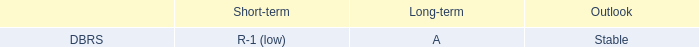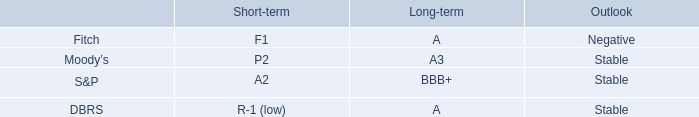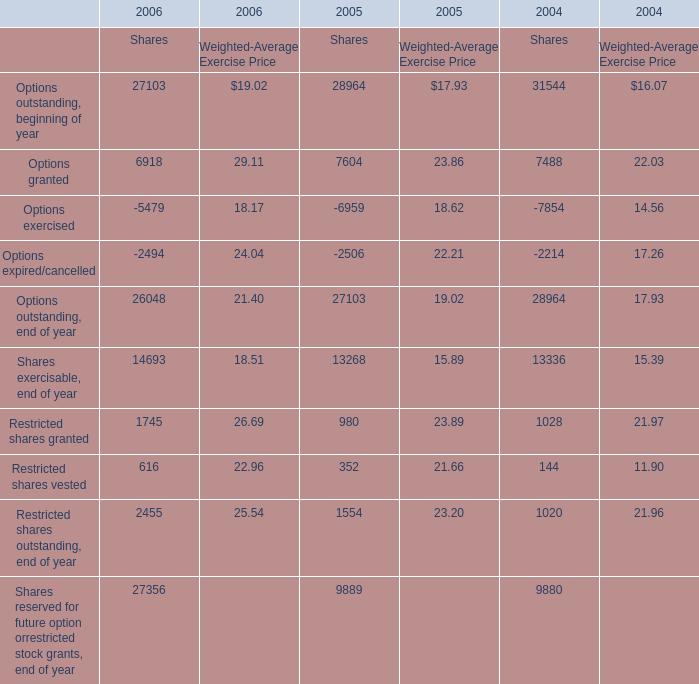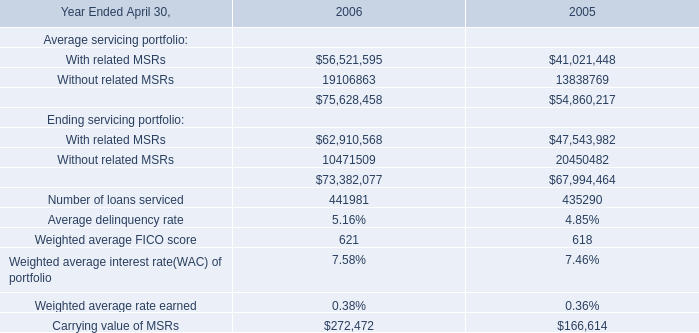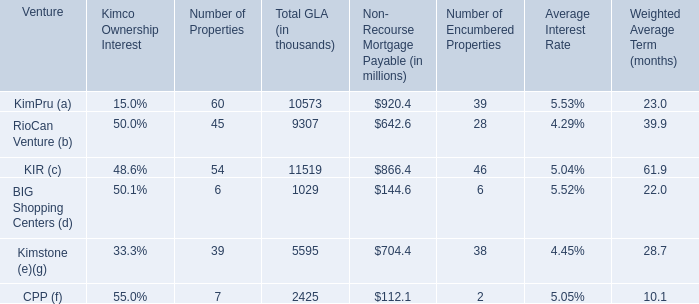What is the total amount of Without related MSRs of 2006, and Restricted shares outstanding, end of year of 2004 Shares ? 
Computations: (19106863.0 + 1020.0)
Answer: 19107883.0. 